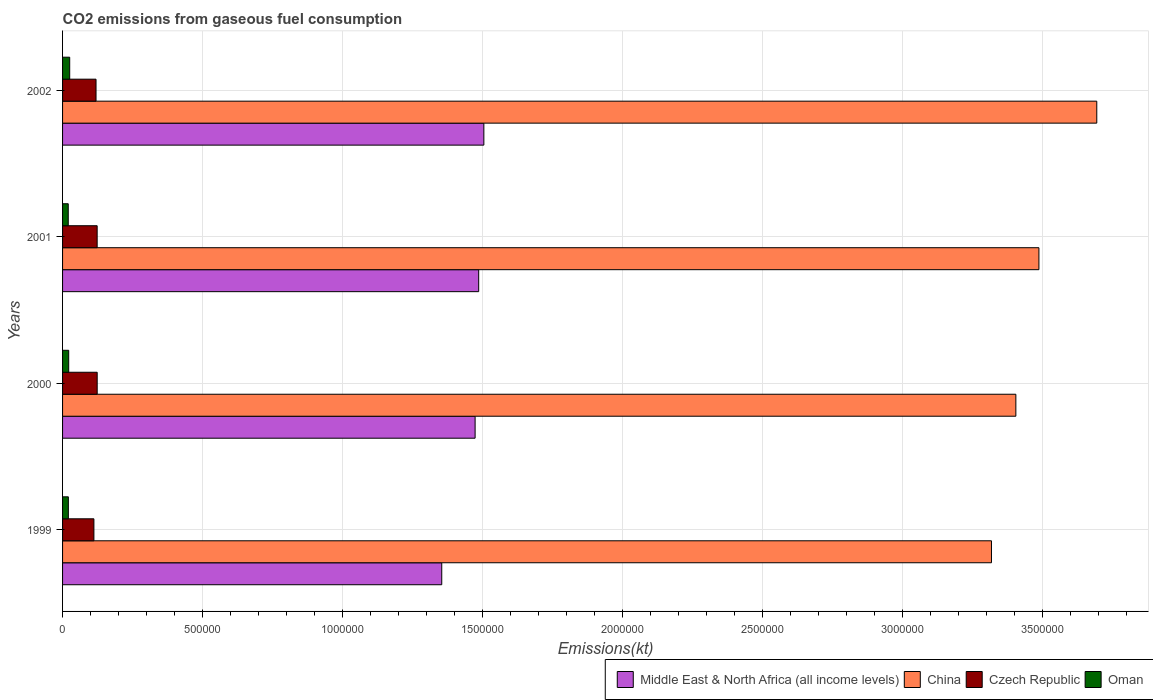How many groups of bars are there?
Offer a very short reply. 4. In how many cases, is the number of bars for a given year not equal to the number of legend labels?
Your answer should be compact. 0. What is the amount of CO2 emitted in Oman in 1999?
Your answer should be compact. 2.07e+04. Across all years, what is the maximum amount of CO2 emitted in Czech Republic?
Your answer should be compact. 1.24e+05. Across all years, what is the minimum amount of CO2 emitted in Middle East & North Africa (all income levels)?
Your answer should be compact. 1.35e+06. In which year was the amount of CO2 emitted in Czech Republic maximum?
Your answer should be very brief. 2000. In which year was the amount of CO2 emitted in China minimum?
Ensure brevity in your answer.  1999. What is the total amount of CO2 emitted in Czech Republic in the graph?
Keep it short and to the point. 4.79e+05. What is the difference between the amount of CO2 emitted in China in 2000 and that in 2001?
Ensure brevity in your answer.  -8.24e+04. What is the difference between the amount of CO2 emitted in Oman in 2000 and the amount of CO2 emitted in Middle East & North Africa (all income levels) in 2002?
Provide a short and direct response. -1.48e+06. What is the average amount of CO2 emitted in Middle East & North Africa (all income levels) per year?
Your answer should be very brief. 1.45e+06. In the year 2000, what is the difference between the amount of CO2 emitted in Czech Republic and amount of CO2 emitted in Oman?
Provide a succinct answer. 1.02e+05. What is the ratio of the amount of CO2 emitted in Oman in 1999 to that in 2001?
Your answer should be compact. 1.02. Is the amount of CO2 emitted in Middle East & North Africa (all income levels) in 2001 less than that in 2002?
Your answer should be compact. Yes. Is the difference between the amount of CO2 emitted in Czech Republic in 1999 and 2000 greater than the difference between the amount of CO2 emitted in Oman in 1999 and 2000?
Ensure brevity in your answer.  No. What is the difference between the highest and the second highest amount of CO2 emitted in Middle East & North Africa (all income levels)?
Provide a succinct answer. 1.85e+04. What is the difference between the highest and the lowest amount of CO2 emitted in Czech Republic?
Offer a very short reply. 1.17e+04. Is the sum of the amount of CO2 emitted in Middle East & North Africa (all income levels) in 2001 and 2002 greater than the maximum amount of CO2 emitted in Oman across all years?
Make the answer very short. Yes. What does the 3rd bar from the top in 2000 represents?
Your answer should be very brief. China. What does the 3rd bar from the bottom in 2000 represents?
Offer a terse response. Czech Republic. How many bars are there?
Your answer should be compact. 16. How many years are there in the graph?
Offer a terse response. 4. What is the difference between two consecutive major ticks on the X-axis?
Keep it short and to the point. 5.00e+05. Are the values on the major ticks of X-axis written in scientific E-notation?
Offer a terse response. No. Does the graph contain grids?
Give a very brief answer. Yes. Where does the legend appear in the graph?
Provide a short and direct response. Bottom right. What is the title of the graph?
Your response must be concise. CO2 emissions from gaseous fuel consumption. Does "Slovenia" appear as one of the legend labels in the graph?
Your response must be concise. No. What is the label or title of the X-axis?
Ensure brevity in your answer.  Emissions(kt). What is the Emissions(kt) of Middle East & North Africa (all income levels) in 1999?
Ensure brevity in your answer.  1.35e+06. What is the Emissions(kt) of China in 1999?
Keep it short and to the point. 3.32e+06. What is the Emissions(kt) of Czech Republic in 1999?
Ensure brevity in your answer.  1.12e+05. What is the Emissions(kt) of Oman in 1999?
Your answer should be compact. 2.07e+04. What is the Emissions(kt) of Middle East & North Africa (all income levels) in 2000?
Provide a succinct answer. 1.47e+06. What is the Emissions(kt) in China in 2000?
Provide a short and direct response. 3.41e+06. What is the Emissions(kt) in Czech Republic in 2000?
Your answer should be compact. 1.24e+05. What is the Emissions(kt) of Oman in 2000?
Provide a short and direct response. 2.19e+04. What is the Emissions(kt) of Middle East & North Africa (all income levels) in 2001?
Your response must be concise. 1.49e+06. What is the Emissions(kt) of China in 2001?
Your response must be concise. 3.49e+06. What is the Emissions(kt) of Czech Republic in 2001?
Give a very brief answer. 1.24e+05. What is the Emissions(kt) of Oman in 2001?
Your response must be concise. 2.03e+04. What is the Emissions(kt) in Middle East & North Africa (all income levels) in 2002?
Keep it short and to the point. 1.50e+06. What is the Emissions(kt) in China in 2002?
Offer a very short reply. 3.69e+06. What is the Emissions(kt) of Czech Republic in 2002?
Ensure brevity in your answer.  1.20e+05. What is the Emissions(kt) in Oman in 2002?
Offer a very short reply. 2.55e+04. Across all years, what is the maximum Emissions(kt) of Middle East & North Africa (all income levels)?
Ensure brevity in your answer.  1.50e+06. Across all years, what is the maximum Emissions(kt) of China?
Your response must be concise. 3.69e+06. Across all years, what is the maximum Emissions(kt) in Czech Republic?
Provide a short and direct response. 1.24e+05. Across all years, what is the maximum Emissions(kt) in Oman?
Make the answer very short. 2.55e+04. Across all years, what is the minimum Emissions(kt) of Middle East & North Africa (all income levels)?
Offer a very short reply. 1.35e+06. Across all years, what is the minimum Emissions(kt) in China?
Offer a very short reply. 3.32e+06. Across all years, what is the minimum Emissions(kt) in Czech Republic?
Give a very brief answer. 1.12e+05. Across all years, what is the minimum Emissions(kt) in Oman?
Provide a succinct answer. 2.03e+04. What is the total Emissions(kt) of Middle East & North Africa (all income levels) in the graph?
Provide a short and direct response. 5.82e+06. What is the total Emissions(kt) of China in the graph?
Provide a succinct answer. 1.39e+07. What is the total Emissions(kt) in Czech Republic in the graph?
Keep it short and to the point. 4.79e+05. What is the total Emissions(kt) of Oman in the graph?
Your answer should be compact. 8.84e+04. What is the difference between the Emissions(kt) of Middle East & North Africa (all income levels) in 1999 and that in 2000?
Make the answer very short. -1.19e+05. What is the difference between the Emissions(kt) of China in 1999 and that in 2000?
Give a very brief answer. -8.71e+04. What is the difference between the Emissions(kt) in Czech Republic in 1999 and that in 2000?
Make the answer very short. -1.17e+04. What is the difference between the Emissions(kt) of Oman in 1999 and that in 2000?
Give a very brief answer. -1188.11. What is the difference between the Emissions(kt) of Middle East & North Africa (all income levels) in 1999 and that in 2001?
Your answer should be compact. -1.32e+05. What is the difference between the Emissions(kt) of China in 1999 and that in 2001?
Make the answer very short. -1.70e+05. What is the difference between the Emissions(kt) in Czech Republic in 1999 and that in 2001?
Your answer should be very brief. -1.16e+04. What is the difference between the Emissions(kt) of Oman in 1999 and that in 2001?
Your response must be concise. 421.7. What is the difference between the Emissions(kt) in Middle East & North Africa (all income levels) in 1999 and that in 2002?
Provide a succinct answer. -1.50e+05. What is the difference between the Emissions(kt) in China in 1999 and that in 2002?
Your answer should be very brief. -3.76e+05. What is the difference between the Emissions(kt) of Czech Republic in 1999 and that in 2002?
Make the answer very short. -7612.69. What is the difference between the Emissions(kt) in Oman in 1999 and that in 2002?
Your response must be concise. -4763.43. What is the difference between the Emissions(kt) of Middle East & North Africa (all income levels) in 2000 and that in 2001?
Make the answer very short. -1.28e+04. What is the difference between the Emissions(kt) of China in 2000 and that in 2001?
Your answer should be very brief. -8.24e+04. What is the difference between the Emissions(kt) in Czech Republic in 2000 and that in 2001?
Provide a short and direct response. 135.68. What is the difference between the Emissions(kt) in Oman in 2000 and that in 2001?
Give a very brief answer. 1609.81. What is the difference between the Emissions(kt) in Middle East & North Africa (all income levels) in 2000 and that in 2002?
Keep it short and to the point. -3.12e+04. What is the difference between the Emissions(kt) of China in 2000 and that in 2002?
Provide a short and direct response. -2.89e+05. What is the difference between the Emissions(kt) in Czech Republic in 2000 and that in 2002?
Make the answer very short. 4132.71. What is the difference between the Emissions(kt) in Oman in 2000 and that in 2002?
Your answer should be very brief. -3575.32. What is the difference between the Emissions(kt) in Middle East & North Africa (all income levels) in 2001 and that in 2002?
Keep it short and to the point. -1.85e+04. What is the difference between the Emissions(kt) of China in 2001 and that in 2002?
Your answer should be compact. -2.07e+05. What is the difference between the Emissions(kt) in Czech Republic in 2001 and that in 2002?
Your answer should be compact. 3997.03. What is the difference between the Emissions(kt) of Oman in 2001 and that in 2002?
Offer a terse response. -5185.14. What is the difference between the Emissions(kt) of Middle East & North Africa (all income levels) in 1999 and the Emissions(kt) of China in 2000?
Give a very brief answer. -2.05e+06. What is the difference between the Emissions(kt) of Middle East & North Africa (all income levels) in 1999 and the Emissions(kt) of Czech Republic in 2000?
Your response must be concise. 1.23e+06. What is the difference between the Emissions(kt) of Middle East & North Africa (all income levels) in 1999 and the Emissions(kt) of Oman in 2000?
Provide a short and direct response. 1.33e+06. What is the difference between the Emissions(kt) in China in 1999 and the Emissions(kt) in Czech Republic in 2000?
Give a very brief answer. 3.19e+06. What is the difference between the Emissions(kt) in China in 1999 and the Emissions(kt) in Oman in 2000?
Offer a terse response. 3.30e+06. What is the difference between the Emissions(kt) in Czech Republic in 1999 and the Emissions(kt) in Oman in 2000?
Provide a succinct answer. 9.00e+04. What is the difference between the Emissions(kt) of Middle East & North Africa (all income levels) in 1999 and the Emissions(kt) of China in 2001?
Give a very brief answer. -2.13e+06. What is the difference between the Emissions(kt) in Middle East & North Africa (all income levels) in 1999 and the Emissions(kt) in Czech Republic in 2001?
Your answer should be very brief. 1.23e+06. What is the difference between the Emissions(kt) in Middle East & North Africa (all income levels) in 1999 and the Emissions(kt) in Oman in 2001?
Offer a very short reply. 1.33e+06. What is the difference between the Emissions(kt) of China in 1999 and the Emissions(kt) of Czech Republic in 2001?
Your response must be concise. 3.19e+06. What is the difference between the Emissions(kt) of China in 1999 and the Emissions(kt) of Oman in 2001?
Offer a very short reply. 3.30e+06. What is the difference between the Emissions(kt) of Czech Republic in 1999 and the Emissions(kt) of Oman in 2001?
Your answer should be compact. 9.17e+04. What is the difference between the Emissions(kt) in Middle East & North Africa (all income levels) in 1999 and the Emissions(kt) in China in 2002?
Keep it short and to the point. -2.34e+06. What is the difference between the Emissions(kt) in Middle East & North Africa (all income levels) in 1999 and the Emissions(kt) in Czech Republic in 2002?
Keep it short and to the point. 1.23e+06. What is the difference between the Emissions(kt) of Middle East & North Africa (all income levels) in 1999 and the Emissions(kt) of Oman in 2002?
Provide a succinct answer. 1.33e+06. What is the difference between the Emissions(kt) of China in 1999 and the Emissions(kt) of Czech Republic in 2002?
Your answer should be compact. 3.20e+06. What is the difference between the Emissions(kt) of China in 1999 and the Emissions(kt) of Oman in 2002?
Your answer should be compact. 3.29e+06. What is the difference between the Emissions(kt) in Czech Republic in 1999 and the Emissions(kt) in Oman in 2002?
Keep it short and to the point. 8.65e+04. What is the difference between the Emissions(kt) in Middle East & North Africa (all income levels) in 2000 and the Emissions(kt) in China in 2001?
Make the answer very short. -2.01e+06. What is the difference between the Emissions(kt) in Middle East & North Africa (all income levels) in 2000 and the Emissions(kt) in Czech Republic in 2001?
Your response must be concise. 1.35e+06. What is the difference between the Emissions(kt) in Middle East & North Africa (all income levels) in 2000 and the Emissions(kt) in Oman in 2001?
Your response must be concise. 1.45e+06. What is the difference between the Emissions(kt) in China in 2000 and the Emissions(kt) in Czech Republic in 2001?
Your answer should be very brief. 3.28e+06. What is the difference between the Emissions(kt) of China in 2000 and the Emissions(kt) of Oman in 2001?
Ensure brevity in your answer.  3.38e+06. What is the difference between the Emissions(kt) in Czech Republic in 2000 and the Emissions(kt) in Oman in 2001?
Provide a succinct answer. 1.03e+05. What is the difference between the Emissions(kt) of Middle East & North Africa (all income levels) in 2000 and the Emissions(kt) of China in 2002?
Your answer should be very brief. -2.22e+06. What is the difference between the Emissions(kt) in Middle East & North Africa (all income levels) in 2000 and the Emissions(kt) in Czech Republic in 2002?
Your answer should be very brief. 1.35e+06. What is the difference between the Emissions(kt) of Middle East & North Africa (all income levels) in 2000 and the Emissions(kt) of Oman in 2002?
Provide a short and direct response. 1.45e+06. What is the difference between the Emissions(kt) of China in 2000 and the Emissions(kt) of Czech Republic in 2002?
Make the answer very short. 3.29e+06. What is the difference between the Emissions(kt) in China in 2000 and the Emissions(kt) in Oman in 2002?
Offer a terse response. 3.38e+06. What is the difference between the Emissions(kt) of Czech Republic in 2000 and the Emissions(kt) of Oman in 2002?
Your answer should be very brief. 9.82e+04. What is the difference between the Emissions(kt) of Middle East & North Africa (all income levels) in 2001 and the Emissions(kt) of China in 2002?
Your answer should be compact. -2.21e+06. What is the difference between the Emissions(kt) in Middle East & North Africa (all income levels) in 2001 and the Emissions(kt) in Czech Republic in 2002?
Your response must be concise. 1.37e+06. What is the difference between the Emissions(kt) of Middle East & North Africa (all income levels) in 2001 and the Emissions(kt) of Oman in 2002?
Keep it short and to the point. 1.46e+06. What is the difference between the Emissions(kt) of China in 2001 and the Emissions(kt) of Czech Republic in 2002?
Ensure brevity in your answer.  3.37e+06. What is the difference between the Emissions(kt) of China in 2001 and the Emissions(kt) of Oman in 2002?
Provide a succinct answer. 3.46e+06. What is the difference between the Emissions(kt) in Czech Republic in 2001 and the Emissions(kt) in Oman in 2002?
Your response must be concise. 9.81e+04. What is the average Emissions(kt) of Middle East & North Africa (all income levels) per year?
Offer a very short reply. 1.45e+06. What is the average Emissions(kt) of China per year?
Provide a succinct answer. 3.48e+06. What is the average Emissions(kt) in Czech Republic per year?
Provide a short and direct response. 1.20e+05. What is the average Emissions(kt) in Oman per year?
Your response must be concise. 2.21e+04. In the year 1999, what is the difference between the Emissions(kt) in Middle East & North Africa (all income levels) and Emissions(kt) in China?
Your response must be concise. -1.96e+06. In the year 1999, what is the difference between the Emissions(kt) in Middle East & North Africa (all income levels) and Emissions(kt) in Czech Republic?
Provide a succinct answer. 1.24e+06. In the year 1999, what is the difference between the Emissions(kt) in Middle East & North Africa (all income levels) and Emissions(kt) in Oman?
Your answer should be very brief. 1.33e+06. In the year 1999, what is the difference between the Emissions(kt) in China and Emissions(kt) in Czech Republic?
Give a very brief answer. 3.21e+06. In the year 1999, what is the difference between the Emissions(kt) in China and Emissions(kt) in Oman?
Make the answer very short. 3.30e+06. In the year 1999, what is the difference between the Emissions(kt) of Czech Republic and Emissions(kt) of Oman?
Offer a very short reply. 9.12e+04. In the year 2000, what is the difference between the Emissions(kt) of Middle East & North Africa (all income levels) and Emissions(kt) of China?
Your answer should be compact. -1.93e+06. In the year 2000, what is the difference between the Emissions(kt) in Middle East & North Africa (all income levels) and Emissions(kt) in Czech Republic?
Provide a short and direct response. 1.35e+06. In the year 2000, what is the difference between the Emissions(kt) in Middle East & North Africa (all income levels) and Emissions(kt) in Oman?
Your answer should be compact. 1.45e+06. In the year 2000, what is the difference between the Emissions(kt) in China and Emissions(kt) in Czech Republic?
Make the answer very short. 3.28e+06. In the year 2000, what is the difference between the Emissions(kt) in China and Emissions(kt) in Oman?
Provide a short and direct response. 3.38e+06. In the year 2000, what is the difference between the Emissions(kt) in Czech Republic and Emissions(kt) in Oman?
Keep it short and to the point. 1.02e+05. In the year 2001, what is the difference between the Emissions(kt) in Middle East & North Africa (all income levels) and Emissions(kt) in China?
Provide a short and direct response. -2.00e+06. In the year 2001, what is the difference between the Emissions(kt) in Middle East & North Africa (all income levels) and Emissions(kt) in Czech Republic?
Keep it short and to the point. 1.36e+06. In the year 2001, what is the difference between the Emissions(kt) of Middle East & North Africa (all income levels) and Emissions(kt) of Oman?
Provide a short and direct response. 1.47e+06. In the year 2001, what is the difference between the Emissions(kt) of China and Emissions(kt) of Czech Republic?
Keep it short and to the point. 3.36e+06. In the year 2001, what is the difference between the Emissions(kt) of China and Emissions(kt) of Oman?
Offer a very short reply. 3.47e+06. In the year 2001, what is the difference between the Emissions(kt) of Czech Republic and Emissions(kt) of Oman?
Offer a very short reply. 1.03e+05. In the year 2002, what is the difference between the Emissions(kt) in Middle East & North Africa (all income levels) and Emissions(kt) in China?
Offer a very short reply. -2.19e+06. In the year 2002, what is the difference between the Emissions(kt) of Middle East & North Africa (all income levels) and Emissions(kt) of Czech Republic?
Ensure brevity in your answer.  1.39e+06. In the year 2002, what is the difference between the Emissions(kt) in Middle East & North Africa (all income levels) and Emissions(kt) in Oman?
Ensure brevity in your answer.  1.48e+06. In the year 2002, what is the difference between the Emissions(kt) of China and Emissions(kt) of Czech Republic?
Provide a short and direct response. 3.57e+06. In the year 2002, what is the difference between the Emissions(kt) of China and Emissions(kt) of Oman?
Your answer should be compact. 3.67e+06. In the year 2002, what is the difference between the Emissions(kt) of Czech Republic and Emissions(kt) of Oman?
Ensure brevity in your answer.  9.41e+04. What is the ratio of the Emissions(kt) of Middle East & North Africa (all income levels) in 1999 to that in 2000?
Provide a short and direct response. 0.92. What is the ratio of the Emissions(kt) of China in 1999 to that in 2000?
Offer a terse response. 0.97. What is the ratio of the Emissions(kt) in Czech Republic in 1999 to that in 2000?
Your answer should be compact. 0.91. What is the ratio of the Emissions(kt) of Oman in 1999 to that in 2000?
Provide a short and direct response. 0.95. What is the ratio of the Emissions(kt) in Middle East & North Africa (all income levels) in 1999 to that in 2001?
Your response must be concise. 0.91. What is the ratio of the Emissions(kt) in China in 1999 to that in 2001?
Ensure brevity in your answer.  0.95. What is the ratio of the Emissions(kt) in Czech Republic in 1999 to that in 2001?
Offer a very short reply. 0.91. What is the ratio of the Emissions(kt) in Oman in 1999 to that in 2001?
Your answer should be compact. 1.02. What is the ratio of the Emissions(kt) in Middle East & North Africa (all income levels) in 1999 to that in 2002?
Ensure brevity in your answer.  0.9. What is the ratio of the Emissions(kt) in China in 1999 to that in 2002?
Your answer should be very brief. 0.9. What is the ratio of the Emissions(kt) in Czech Republic in 1999 to that in 2002?
Your response must be concise. 0.94. What is the ratio of the Emissions(kt) of Oman in 1999 to that in 2002?
Ensure brevity in your answer.  0.81. What is the ratio of the Emissions(kt) in Middle East & North Africa (all income levels) in 2000 to that in 2001?
Your answer should be very brief. 0.99. What is the ratio of the Emissions(kt) of China in 2000 to that in 2001?
Offer a very short reply. 0.98. What is the ratio of the Emissions(kt) of Oman in 2000 to that in 2001?
Make the answer very short. 1.08. What is the ratio of the Emissions(kt) in Middle East & North Africa (all income levels) in 2000 to that in 2002?
Provide a succinct answer. 0.98. What is the ratio of the Emissions(kt) in China in 2000 to that in 2002?
Ensure brevity in your answer.  0.92. What is the ratio of the Emissions(kt) in Czech Republic in 2000 to that in 2002?
Provide a succinct answer. 1.03. What is the ratio of the Emissions(kt) of Oman in 2000 to that in 2002?
Give a very brief answer. 0.86. What is the ratio of the Emissions(kt) of China in 2001 to that in 2002?
Provide a short and direct response. 0.94. What is the ratio of the Emissions(kt) of Czech Republic in 2001 to that in 2002?
Give a very brief answer. 1.03. What is the ratio of the Emissions(kt) in Oman in 2001 to that in 2002?
Keep it short and to the point. 0.8. What is the difference between the highest and the second highest Emissions(kt) of Middle East & North Africa (all income levels)?
Provide a succinct answer. 1.85e+04. What is the difference between the highest and the second highest Emissions(kt) of China?
Make the answer very short. 2.07e+05. What is the difference between the highest and the second highest Emissions(kt) of Czech Republic?
Your answer should be compact. 135.68. What is the difference between the highest and the second highest Emissions(kt) of Oman?
Your response must be concise. 3575.32. What is the difference between the highest and the lowest Emissions(kt) in Middle East & North Africa (all income levels)?
Offer a very short reply. 1.50e+05. What is the difference between the highest and the lowest Emissions(kt) in China?
Your answer should be very brief. 3.76e+05. What is the difference between the highest and the lowest Emissions(kt) of Czech Republic?
Offer a very short reply. 1.17e+04. What is the difference between the highest and the lowest Emissions(kt) of Oman?
Ensure brevity in your answer.  5185.14. 